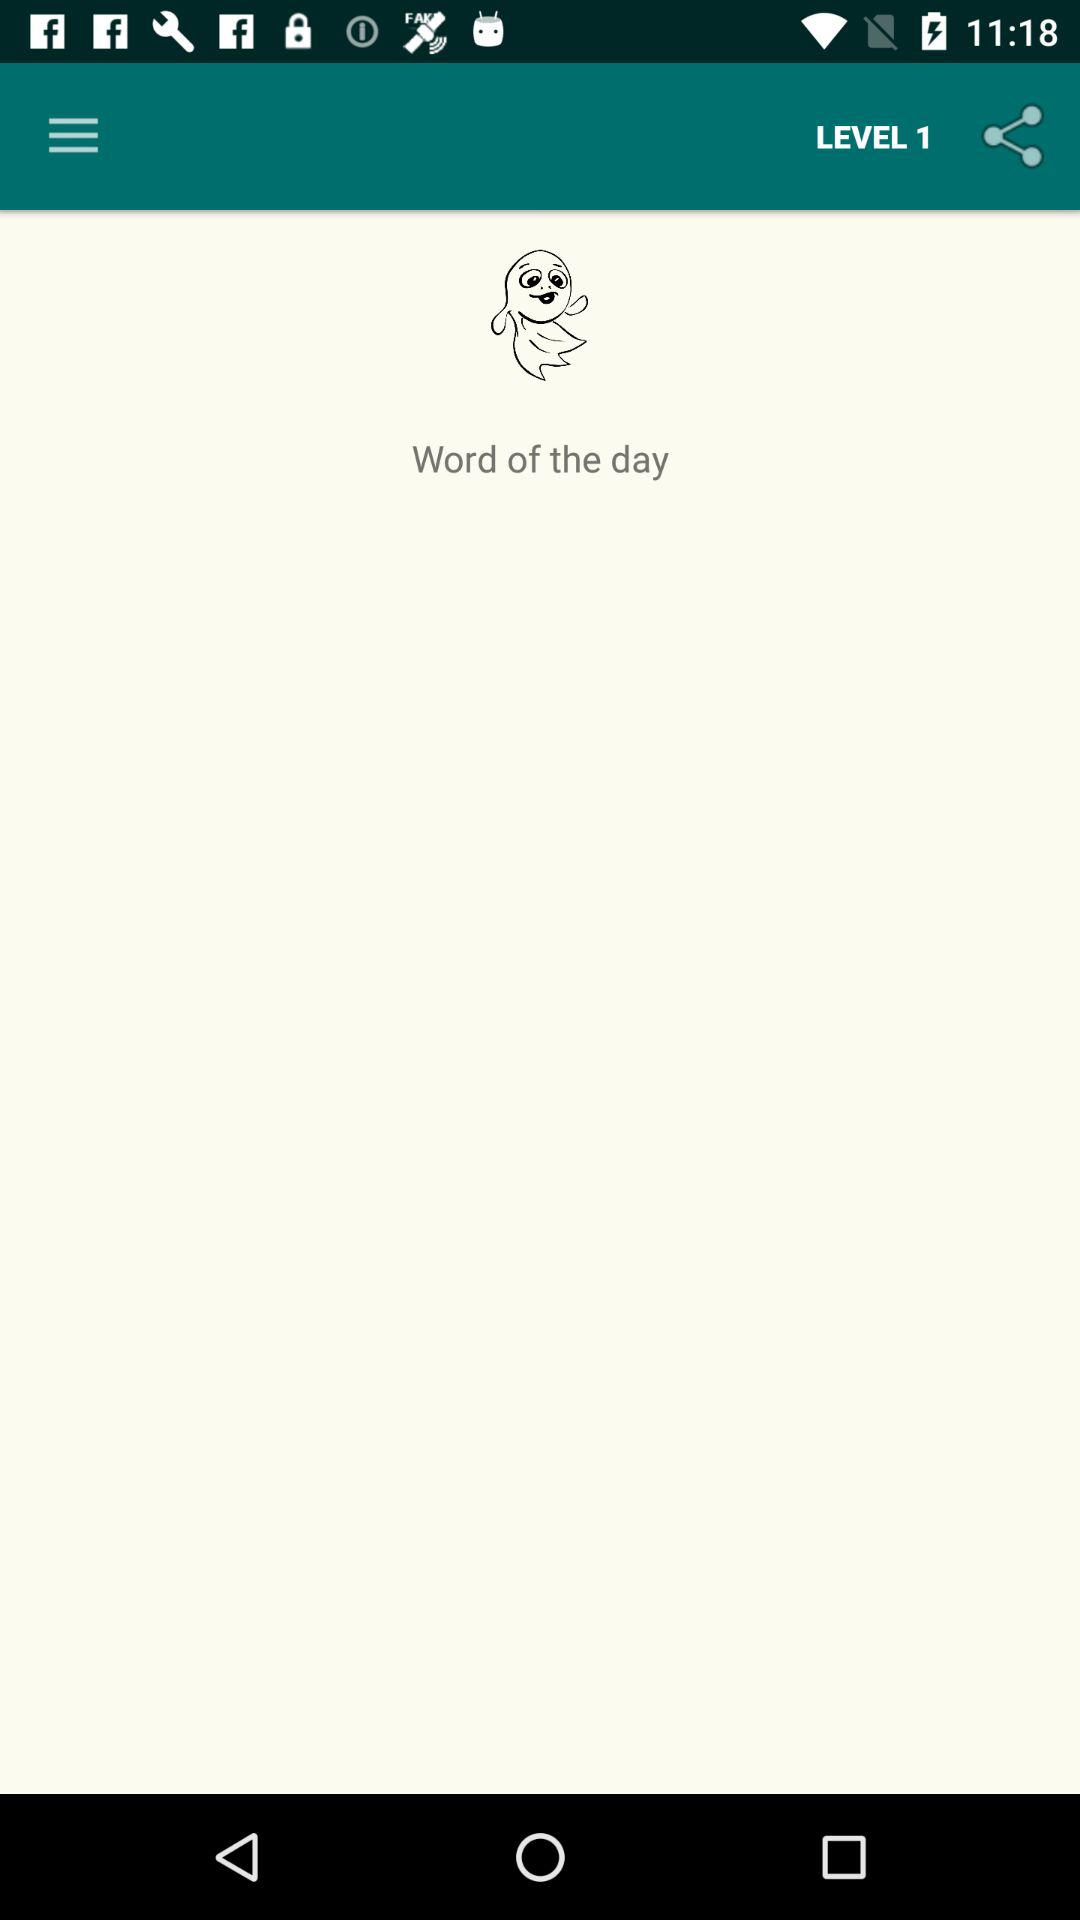How many syllables is in the word of the day?
When the provided information is insufficient, respond with <no answer>. <no answer> 